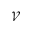<formula> <loc_0><loc_0><loc_500><loc_500>\mathcal { V }</formula> 